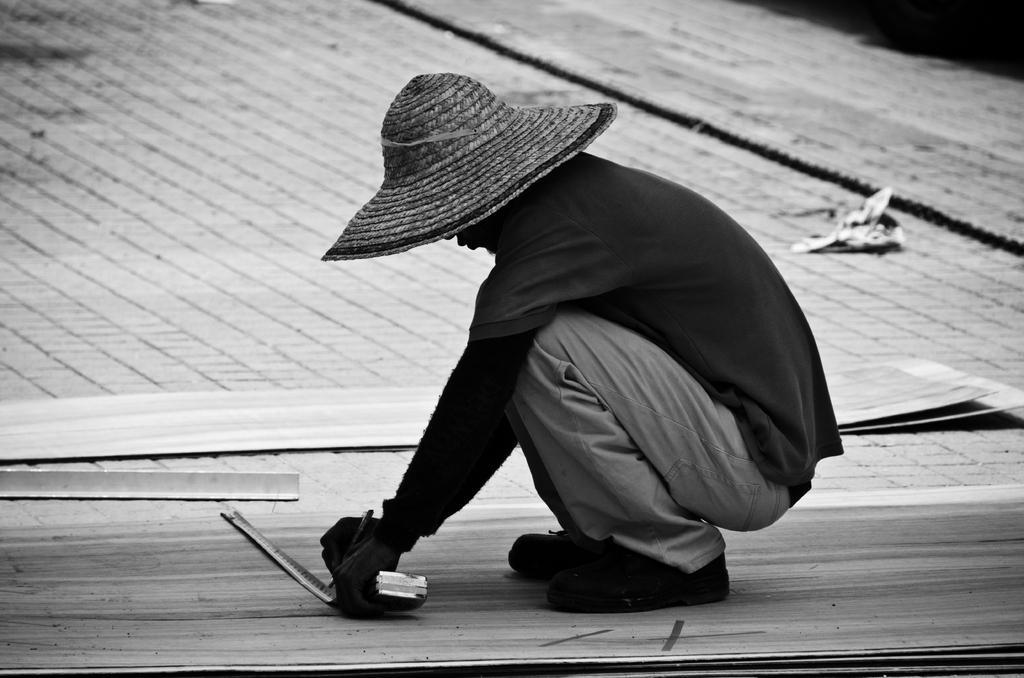Could you give a brief overview of what you see in this image? This picture is in black and white. The man in the middle of the picture wearing black T-shirt and hat is holding a pen and a measuring tape in his hands. Beside him, we see wooden sheets are placed on the road. 